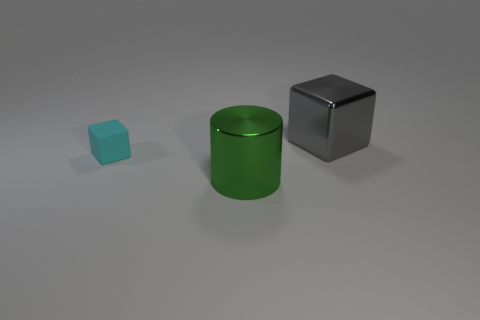Is there anything else that has the same size as the matte block?
Your response must be concise. No. Is the number of big metallic blocks that are behind the large block the same as the number of small gray metal objects?
Provide a succinct answer. Yes. Are there any cylinders that have the same color as the shiny block?
Keep it short and to the point. No. Is the cyan rubber cube the same size as the gray metal object?
Ensure brevity in your answer.  No. What is the size of the cube in front of the metal thing right of the green metallic cylinder?
Your response must be concise. Small. What size is the thing that is to the right of the tiny rubber block and behind the green cylinder?
Ensure brevity in your answer.  Large. What number of green cylinders have the same size as the gray shiny cube?
Keep it short and to the point. 1. What number of matte objects are cyan objects or large green cylinders?
Keep it short and to the point. 1. There is a thing that is to the left of the thing in front of the rubber block; what is it made of?
Provide a short and direct response. Rubber. What number of objects are tiny cyan objects or objects that are on the left side of the green thing?
Make the answer very short. 1. 